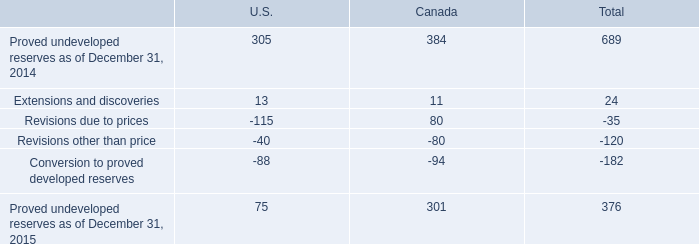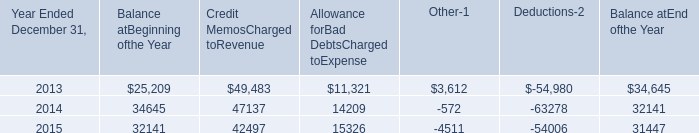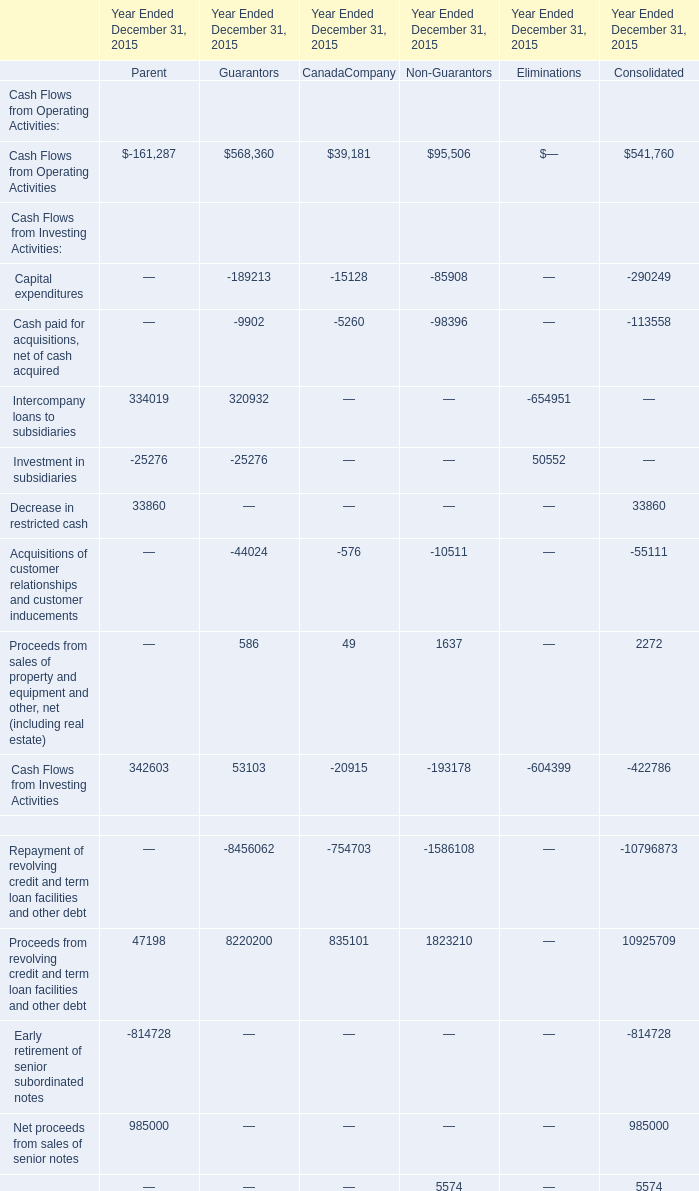What's the sum of all CanadaCompany that are positive in 2015? 
Computations: (((((39181 + 49) + 835101) + 3577) + 8203) + 4979)
Answer: 891090.0. 